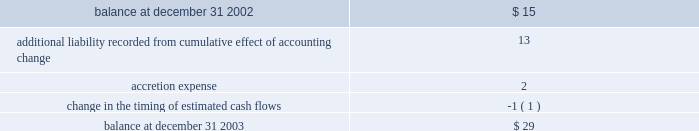Impairment of long-lived assets based on the projection of undiscounted cash flows whenever events or changes in circumstances indicate that the carrying amounts of such assets may not be recoverable .
In the event such cash flows are not expected to be sufficient to recover the recorded value of the assets , the assets are written down to their estimated fair values ( see note 5 ) .
Asset retirement obligations 2014effective january 1 , 2003 , the company adopted statement of financial accounting standards ( 2018 2018sfas 2019 2019 ) no .
143 , 2018 2018accounting for asset retirement obligations . 2019 2019 sfas no .
143 requires the company to record the fair value of a legal liability for an asset retirement obligation in the period in which it is incurred .
When a new liability is recorded the company will capitalize the costs of the liability by increasing the carrying amount of the related long-lived asset .
The liability is accreted to its present value each period and the capitalized cost is depreciated over the useful life of the related asset .
Upon settlement of the liability , the company settles the obligation for its recorded amount or incurs a gain or loss upon settlement .
The company 2019s retirement obligations covered by sfas no .
143 include primarily active ash landfills , water treatment basins and the removal or dismantlement of certain plant and equipment .
As of december 31 , 2003 and 2002 , the company had recorded liabilities of approximately $ 29 million and $ 15 million , respectively , related to asset retirement obligations .
There are no assets that are legally restricted for purposes of settling asset retirement obligations .
Upon adoption of sfas no .
143 , the company recorded an additional liability of approximately $ 13 million , a net asset of approximately $ 9 million , and a cumulative effect of a change in accounting principle of approximately $ 2 million , after income taxes .
Amounts recorded related to asset retirement obligations during the years ended december 31 , 2003 were as follows ( in millions ) : .
Proforma net ( loss ) income and ( loss ) earnings per share have not been presented for the years ended december 31 , 2002 and 2001 because the proforma application of sfas no .
143 to prior periods would result in proforma net ( loss ) income and ( loss ) earnings per share not materially different from the actual amounts reported for those periods in the accompanying consolidated statements of operations .
Had sfas 143 been applied during all periods presented the asset retirement obligation at january 1 , 2001 , december 31 , 2001 and december 31 , 2002 would have been approximately $ 21 million , $ 23 million and $ 28 million , respectively .
Included in other long-term liabilities is the accrual for the non-legal obligations for removal of assets in service at ipalco amounting to $ 361 million and $ 339 million at december 31 , 2003 and 2002 , respectively .
Deferred financing costs 2014financing costs are deferred and amortized over the related financing period using the effective interest method or the straight-line method when it does not differ materially from the effective interest method .
Deferred financing costs are shown net of accumulated amortization of $ 202 million and $ 173 million as of december 31 , 2003 and 2002 , respectively .
Project development costs 2014the company capitalizes the costs of developing new construction projects after achieving certain project-related milestones that indicate the project 2019s completion is probable .
These costs represent amounts incurred for professional services , permits , options , capitalized interest , and other costs directly related to construction .
These costs are transferred to construction in progress when significant construction activity commences , or expensed at the time the company determines that development of a particular project is no longer probable ( see note 5 ) . .
What was the change in asset retirement obligations between 2002 and 2003?\\n? 
Computations: ((29 - 15) * 1000000)
Answer: 14000000.0. 